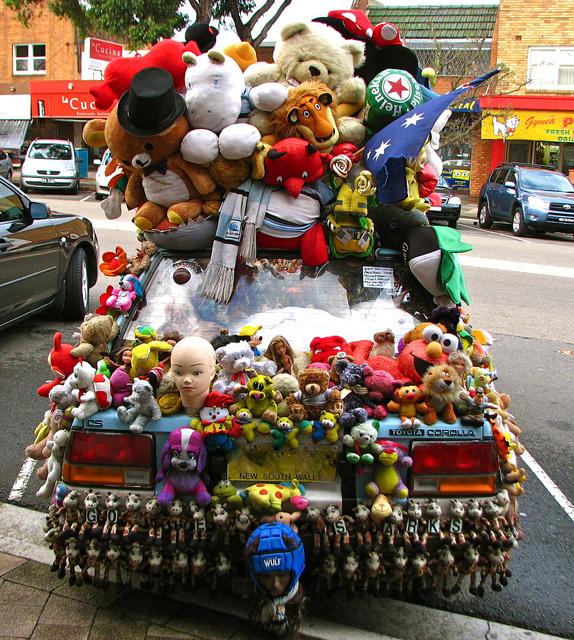Is this a city street?
Quick response, please. Yes. Is this likely an official government vehicle?
Give a very brief answer. No. Is this vehicle safe to drive?
Concise answer only. No. Is there a stuffed heart on the car?
Be succinct. No. 